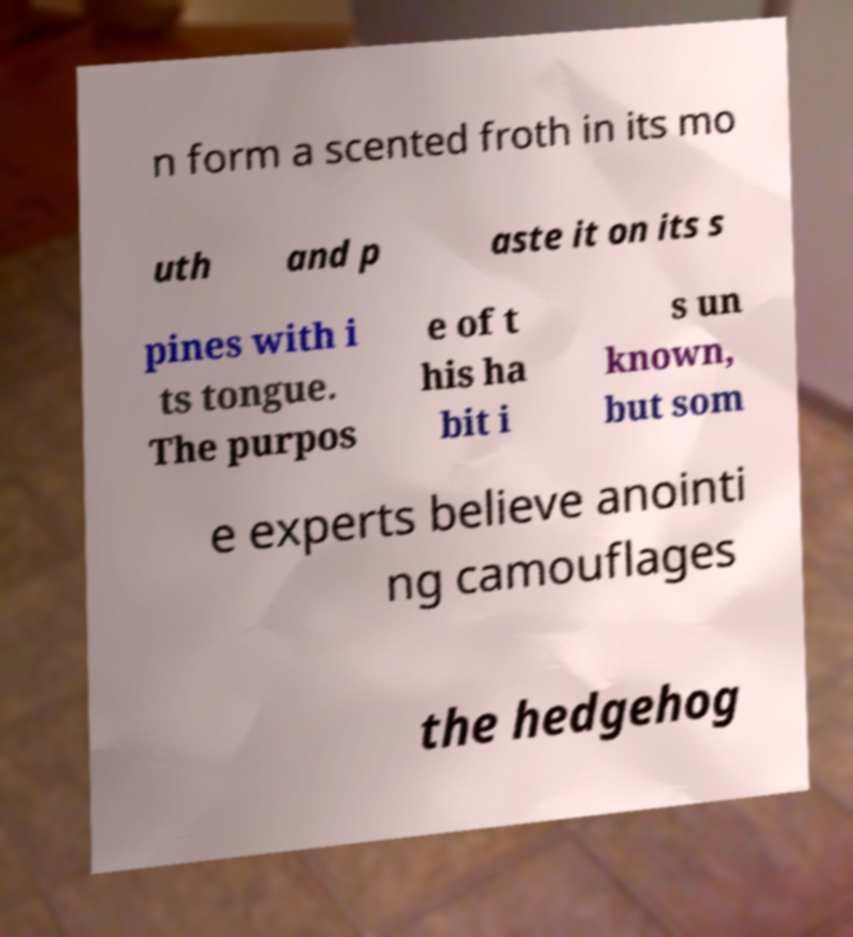Can you accurately transcribe the text from the provided image for me? n form a scented froth in its mo uth and p aste it on its s pines with i ts tongue. The purpos e of t his ha bit i s un known, but som e experts believe anointi ng camouflages the hedgehog 